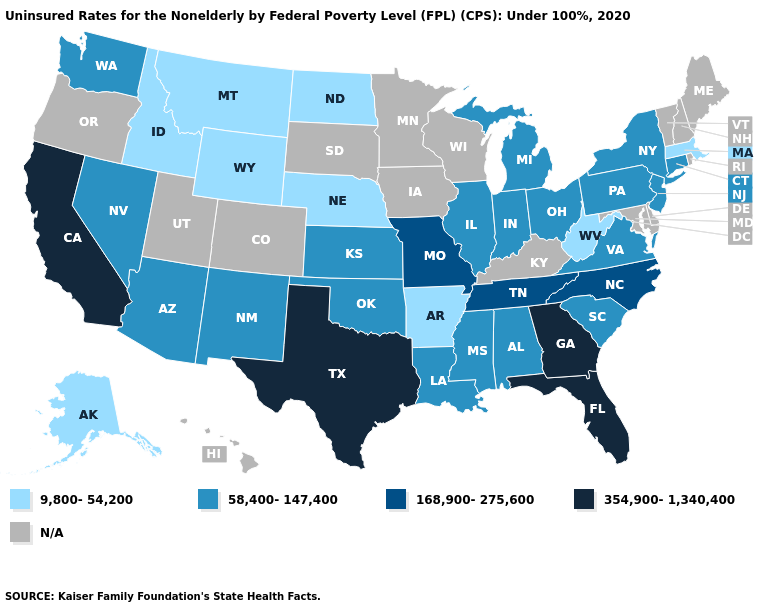Does the map have missing data?
Keep it brief. Yes. Which states have the lowest value in the USA?
Give a very brief answer. Alaska, Arkansas, Idaho, Massachusetts, Montana, Nebraska, North Dakota, West Virginia, Wyoming. Does West Virginia have the lowest value in the USA?
Answer briefly. Yes. Which states have the lowest value in the USA?
Write a very short answer. Alaska, Arkansas, Idaho, Massachusetts, Montana, Nebraska, North Dakota, West Virginia, Wyoming. What is the lowest value in the USA?
Answer briefly. 9,800-54,200. Which states have the lowest value in the USA?
Quick response, please. Alaska, Arkansas, Idaho, Massachusetts, Montana, Nebraska, North Dakota, West Virginia, Wyoming. Does Idaho have the lowest value in the USA?
Keep it brief. Yes. Name the states that have a value in the range 58,400-147,400?
Be succinct. Alabama, Arizona, Connecticut, Illinois, Indiana, Kansas, Louisiana, Michigan, Mississippi, Nevada, New Jersey, New Mexico, New York, Ohio, Oklahoma, Pennsylvania, South Carolina, Virginia, Washington. Name the states that have a value in the range 354,900-1,340,400?
Give a very brief answer. California, Florida, Georgia, Texas. What is the value of Kentucky?
Be succinct. N/A. Which states have the lowest value in the South?
Give a very brief answer. Arkansas, West Virginia. Name the states that have a value in the range 9,800-54,200?
Concise answer only. Alaska, Arkansas, Idaho, Massachusetts, Montana, Nebraska, North Dakota, West Virginia, Wyoming. What is the value of Oklahoma?
Answer briefly. 58,400-147,400. Among the states that border Wisconsin , which have the lowest value?
Quick response, please. Illinois, Michigan. 